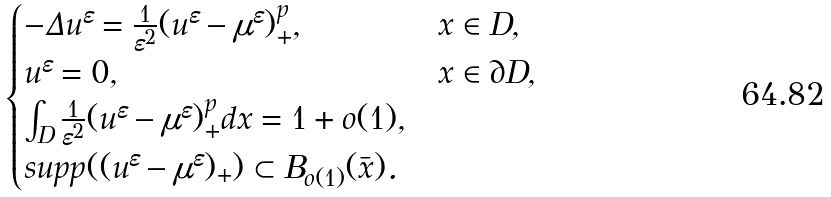<formula> <loc_0><loc_0><loc_500><loc_500>\begin{cases} - \Delta u ^ { \varepsilon } = \frac { 1 } { \varepsilon ^ { 2 } } ( u ^ { \varepsilon } - \mu ^ { \varepsilon } ) _ { + } ^ { p } , & x \in D , \\ u ^ { \varepsilon } = 0 , & x \in \partial D , \\ \int _ { D } \frac { 1 } { \varepsilon ^ { 2 } } ( u ^ { \varepsilon } - \mu ^ { \varepsilon } ) _ { + } ^ { p } d x = 1 + o ( 1 ) , \\ s u p p ( ( u ^ { \varepsilon } - \mu ^ { \varepsilon } ) _ { + } ) \subset B _ { o ( 1 ) } ( \bar { x } ) . \end{cases}</formula> 